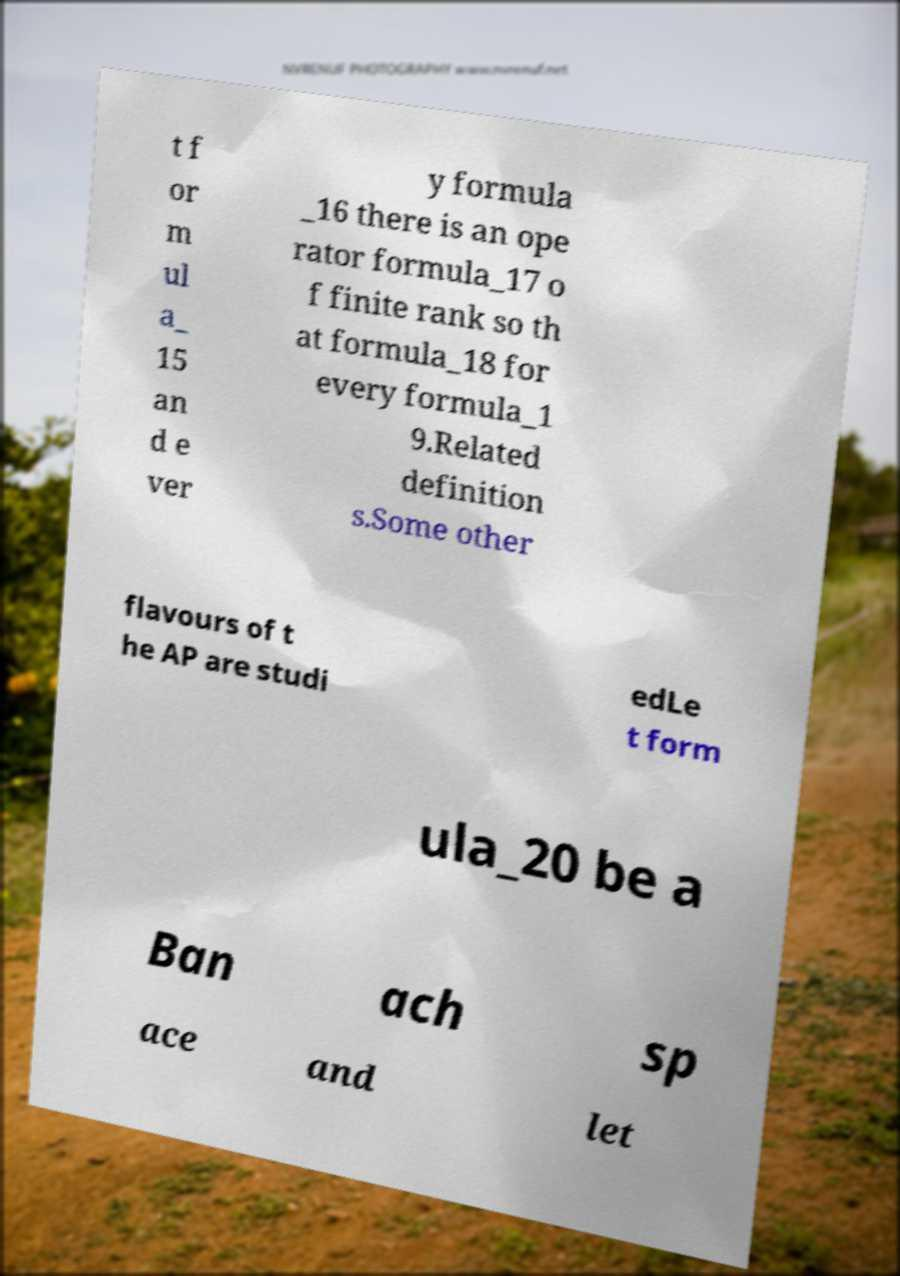What messages or text are displayed in this image? I need them in a readable, typed format. t f or m ul a_ 15 an d e ver y formula _16 there is an ope rator formula_17 o f finite rank so th at formula_18 for every formula_1 9.Related definition s.Some other flavours of t he AP are studi edLe t form ula_20 be a Ban ach sp ace and let 